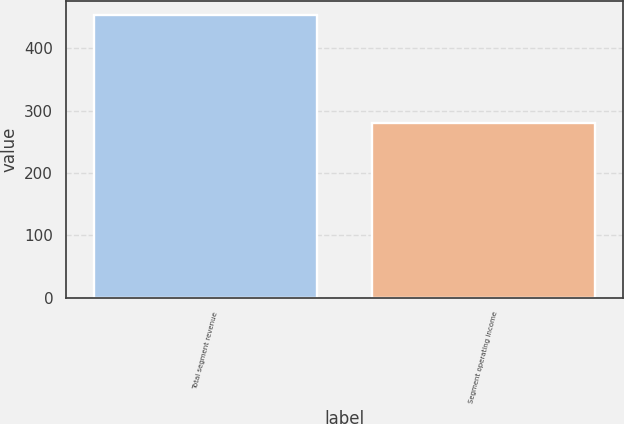Convert chart to OTSL. <chart><loc_0><loc_0><loc_500><loc_500><bar_chart><fcel>Total segment revenue<fcel>Segment operating income<nl><fcel>453<fcel>281<nl></chart> 